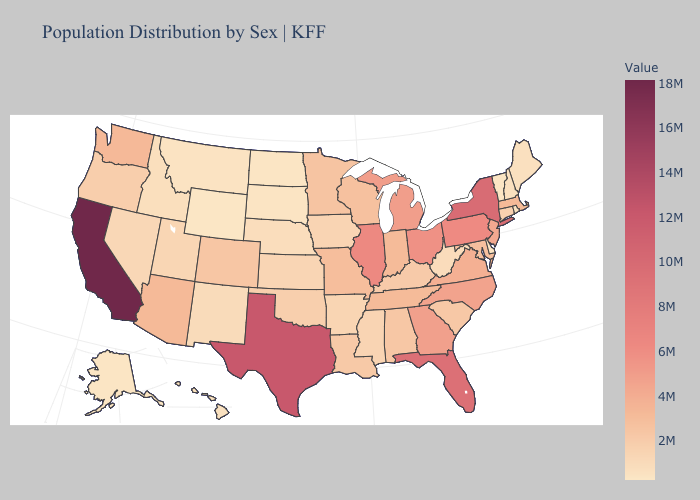Does Alabama have the highest value in the South?
Keep it brief. No. Which states hav the highest value in the MidWest?
Concise answer only. Illinois. Does New Hampshire have the lowest value in the Northeast?
Keep it brief. No. Among the states that border Arkansas , does Louisiana have the lowest value?
Keep it brief. No. Does California have the highest value in the USA?
Concise answer only. Yes. Does California have the highest value in the USA?
Concise answer only. Yes. 